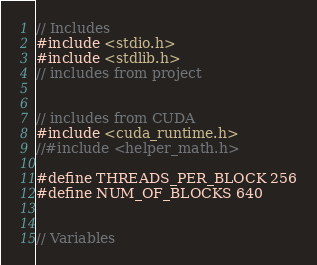<code> <loc_0><loc_0><loc_500><loc_500><_Cuda_>// Includes
#include <stdio.h>
#include <stdlib.h>
// includes from project


// includes from CUDA
#include <cuda_runtime.h>
//#include <helper_math.h>

#define THREADS_PER_BLOCK 256
#define NUM_OF_BLOCKS 640


// Variables</code> 